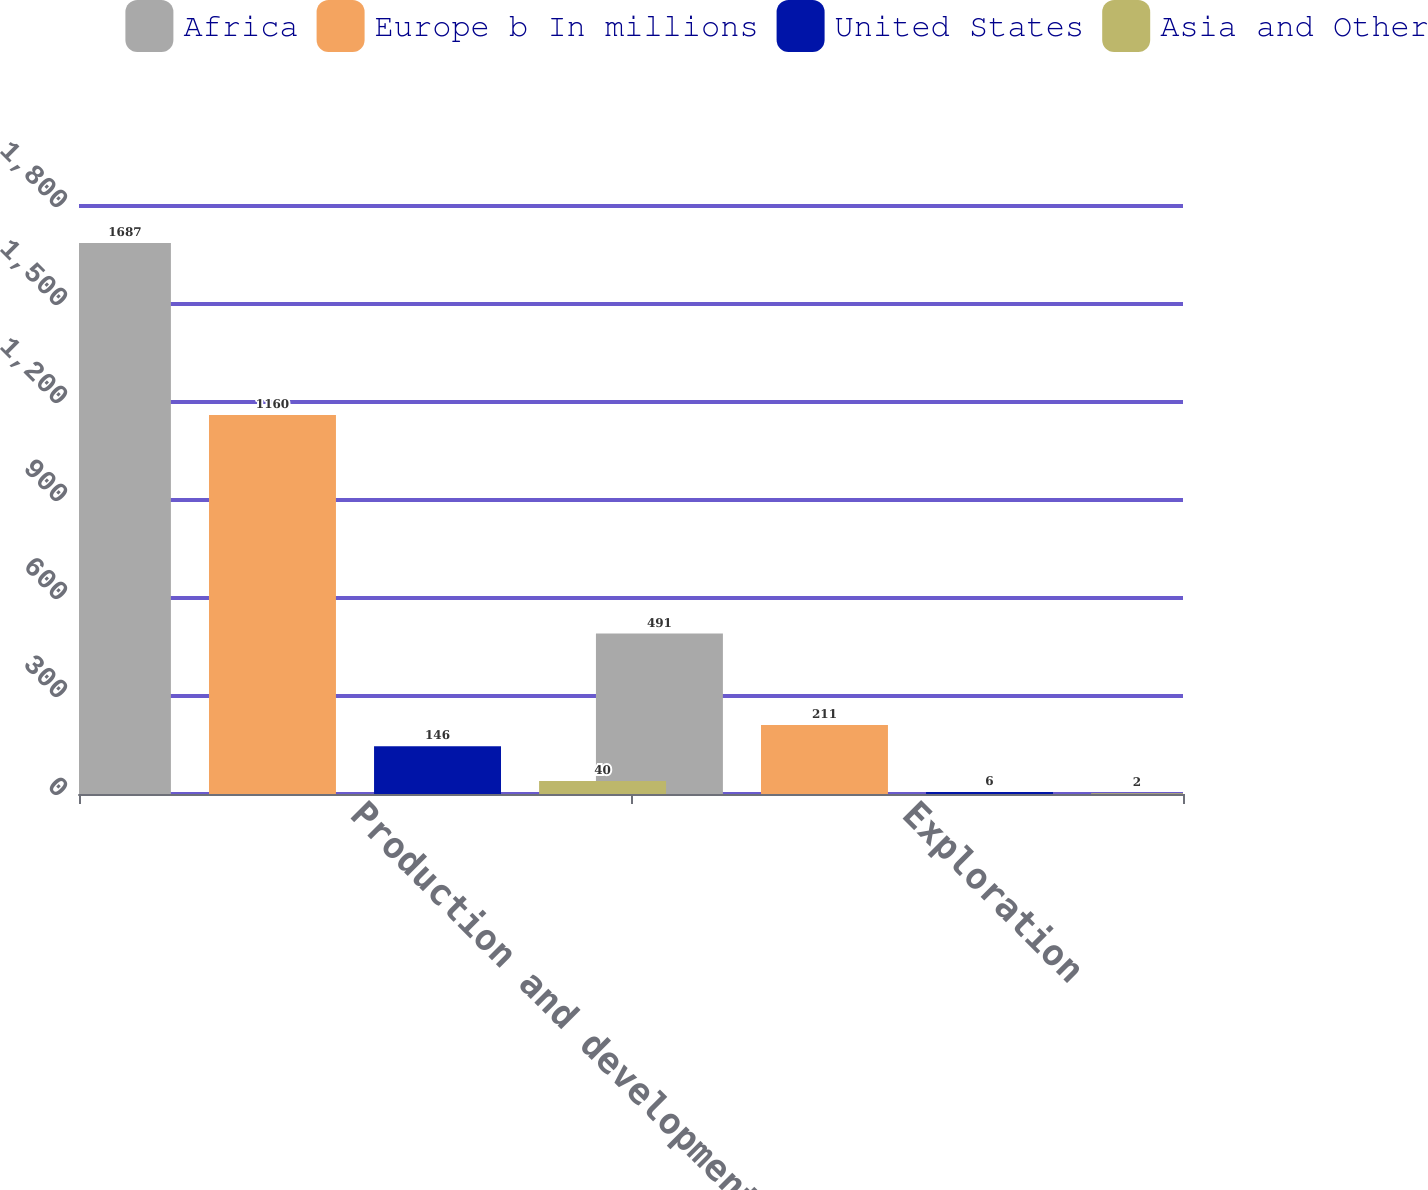Convert chart. <chart><loc_0><loc_0><loc_500><loc_500><stacked_bar_chart><ecel><fcel>Production and development<fcel>Exploration<nl><fcel>Africa<fcel>1687<fcel>491<nl><fcel>Europe b In millions<fcel>1160<fcel>211<nl><fcel>United States<fcel>146<fcel>6<nl><fcel>Asia and Other<fcel>40<fcel>2<nl></chart> 